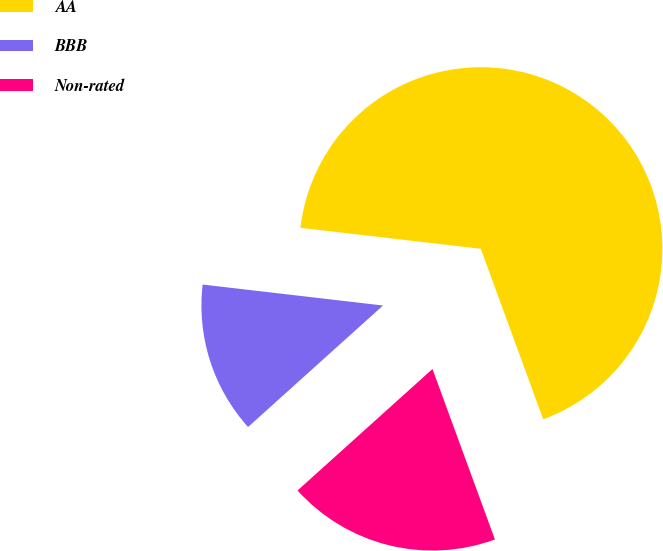Convert chart to OTSL. <chart><loc_0><loc_0><loc_500><loc_500><pie_chart><fcel>AA<fcel>BBB<fcel>Non-rated<nl><fcel>67.57%<fcel>13.51%<fcel>18.92%<nl></chart> 